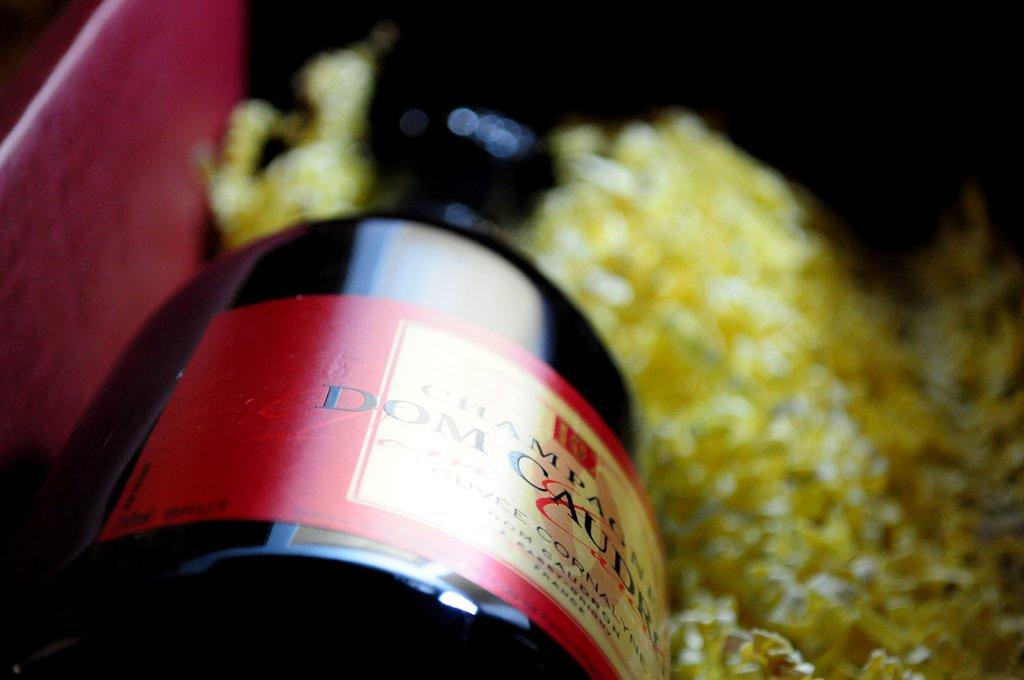<image>
Create a compact narrative representing the image presented. A bottle of champagne lays on it side nestled in shavings. 